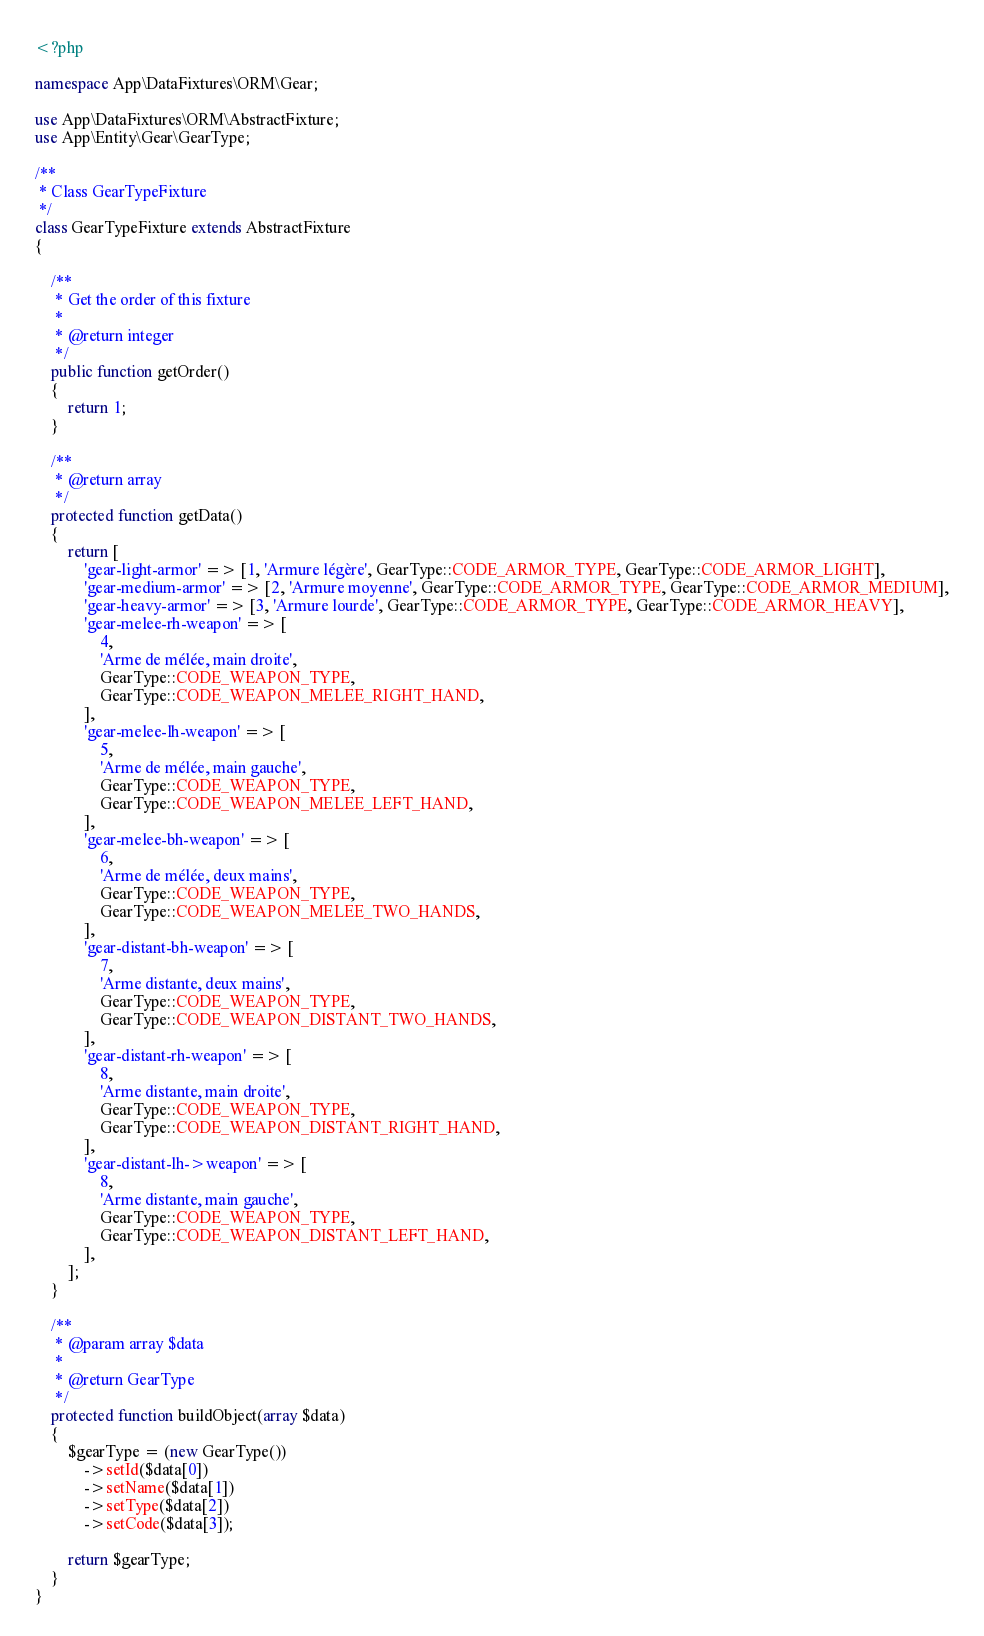Convert code to text. <code><loc_0><loc_0><loc_500><loc_500><_PHP_><?php

namespace App\DataFixtures\ORM\Gear;

use App\DataFixtures\ORM\AbstractFixture;
use App\Entity\Gear\GearType;

/**
 * Class GearTypeFixture
 */
class GearTypeFixture extends AbstractFixture
{

    /**
     * Get the order of this fixture
     *
     * @return integer
     */
    public function getOrder()
    {
        return 1;
    }

    /**
     * @return array
     */
    protected function getData()
    {
        return [
            'gear-light-armor' => [1, 'Armure légère', GearType::CODE_ARMOR_TYPE, GearType::CODE_ARMOR_LIGHT],
            'gear-medium-armor' => [2, 'Armure moyenne', GearType::CODE_ARMOR_TYPE, GearType::CODE_ARMOR_MEDIUM],
            'gear-heavy-armor' => [3, 'Armure lourde', GearType::CODE_ARMOR_TYPE, GearType::CODE_ARMOR_HEAVY],
            'gear-melee-rh-weapon' => [
                4,
                'Arme de mélée, main droite',
                GearType::CODE_WEAPON_TYPE,
                GearType::CODE_WEAPON_MELEE_RIGHT_HAND,
            ],
            'gear-melee-lh-weapon' => [
                5,
                'Arme de mélée, main gauche',
                GearType::CODE_WEAPON_TYPE,
                GearType::CODE_WEAPON_MELEE_LEFT_HAND,
            ],
            'gear-melee-bh-weapon' => [
                6,
                'Arme de mélée, deux mains',
                GearType::CODE_WEAPON_TYPE,
                GearType::CODE_WEAPON_MELEE_TWO_HANDS,
            ],
            'gear-distant-bh-weapon' => [
                7,
                'Arme distante, deux mains',
                GearType::CODE_WEAPON_TYPE,
                GearType::CODE_WEAPON_DISTANT_TWO_HANDS,
            ],
            'gear-distant-rh-weapon' => [
                8,
                'Arme distante, main droite',
                GearType::CODE_WEAPON_TYPE,
                GearType::CODE_WEAPON_DISTANT_RIGHT_HAND,
            ],
            'gear-distant-lh->weapon' => [
                8,
                'Arme distante, main gauche',
                GearType::CODE_WEAPON_TYPE,
                GearType::CODE_WEAPON_DISTANT_LEFT_HAND,
            ],
        ];
    }

    /**
     * @param array $data
     *
     * @return GearType
     */
    protected function buildObject(array $data)
    {
        $gearType = (new GearType())
            ->setId($data[0])
            ->setName($data[1])
            ->setType($data[2])
            ->setCode($data[3]);

        return $gearType;
    }
}
</code> 